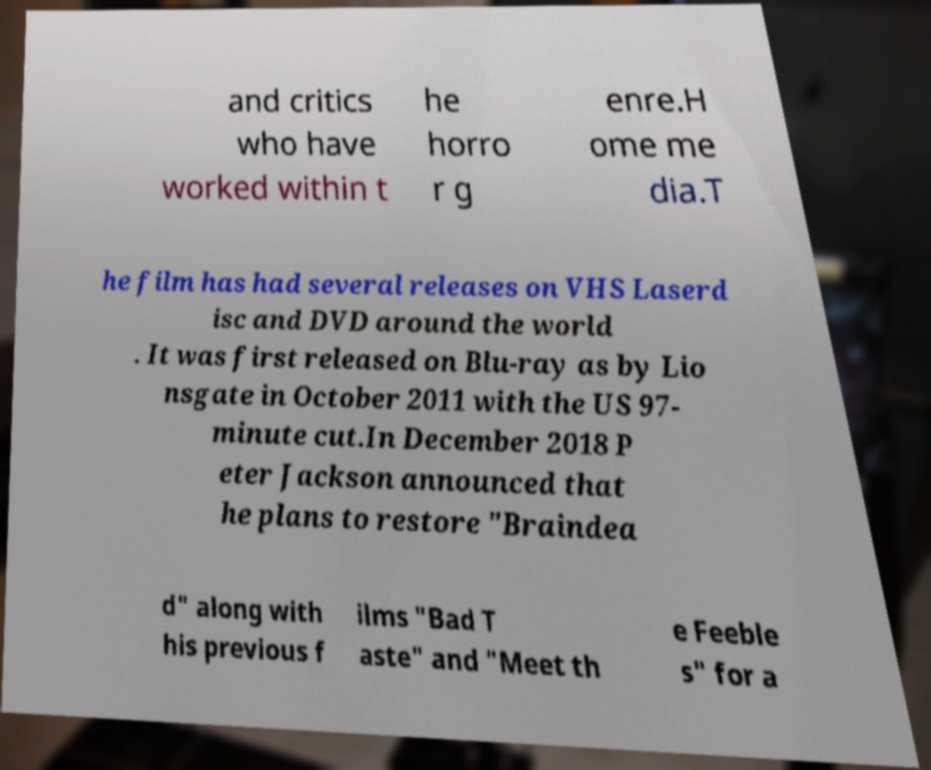For documentation purposes, I need the text within this image transcribed. Could you provide that? and critics who have worked within t he horro r g enre.H ome me dia.T he film has had several releases on VHS Laserd isc and DVD around the world . It was first released on Blu-ray as by Lio nsgate in October 2011 with the US 97- minute cut.In December 2018 P eter Jackson announced that he plans to restore "Braindea d" along with his previous f ilms "Bad T aste" and "Meet th e Feeble s" for a 